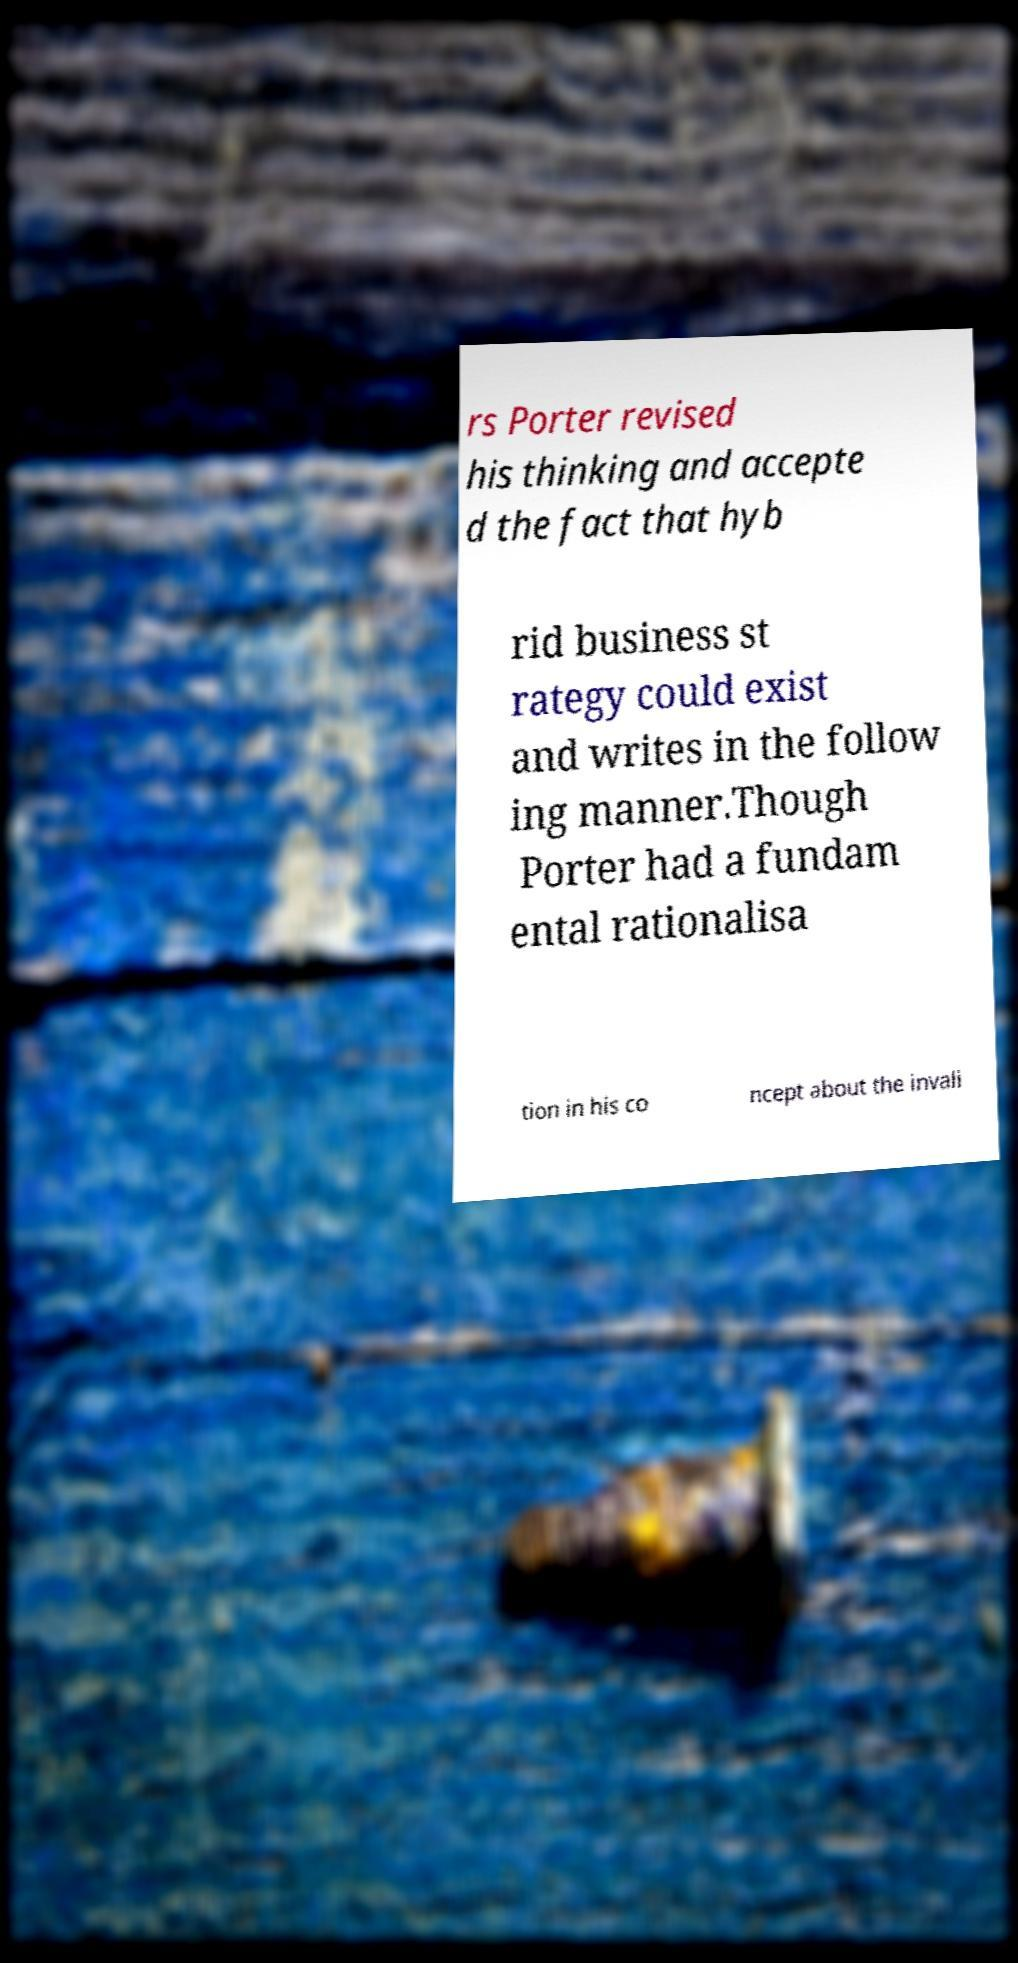There's text embedded in this image that I need extracted. Can you transcribe it verbatim? rs Porter revised his thinking and accepte d the fact that hyb rid business st rategy could exist and writes in the follow ing manner.Though Porter had a fundam ental rationalisa tion in his co ncept about the invali 